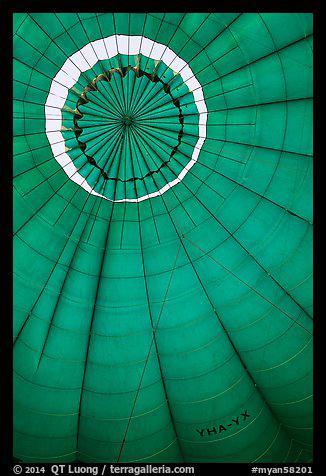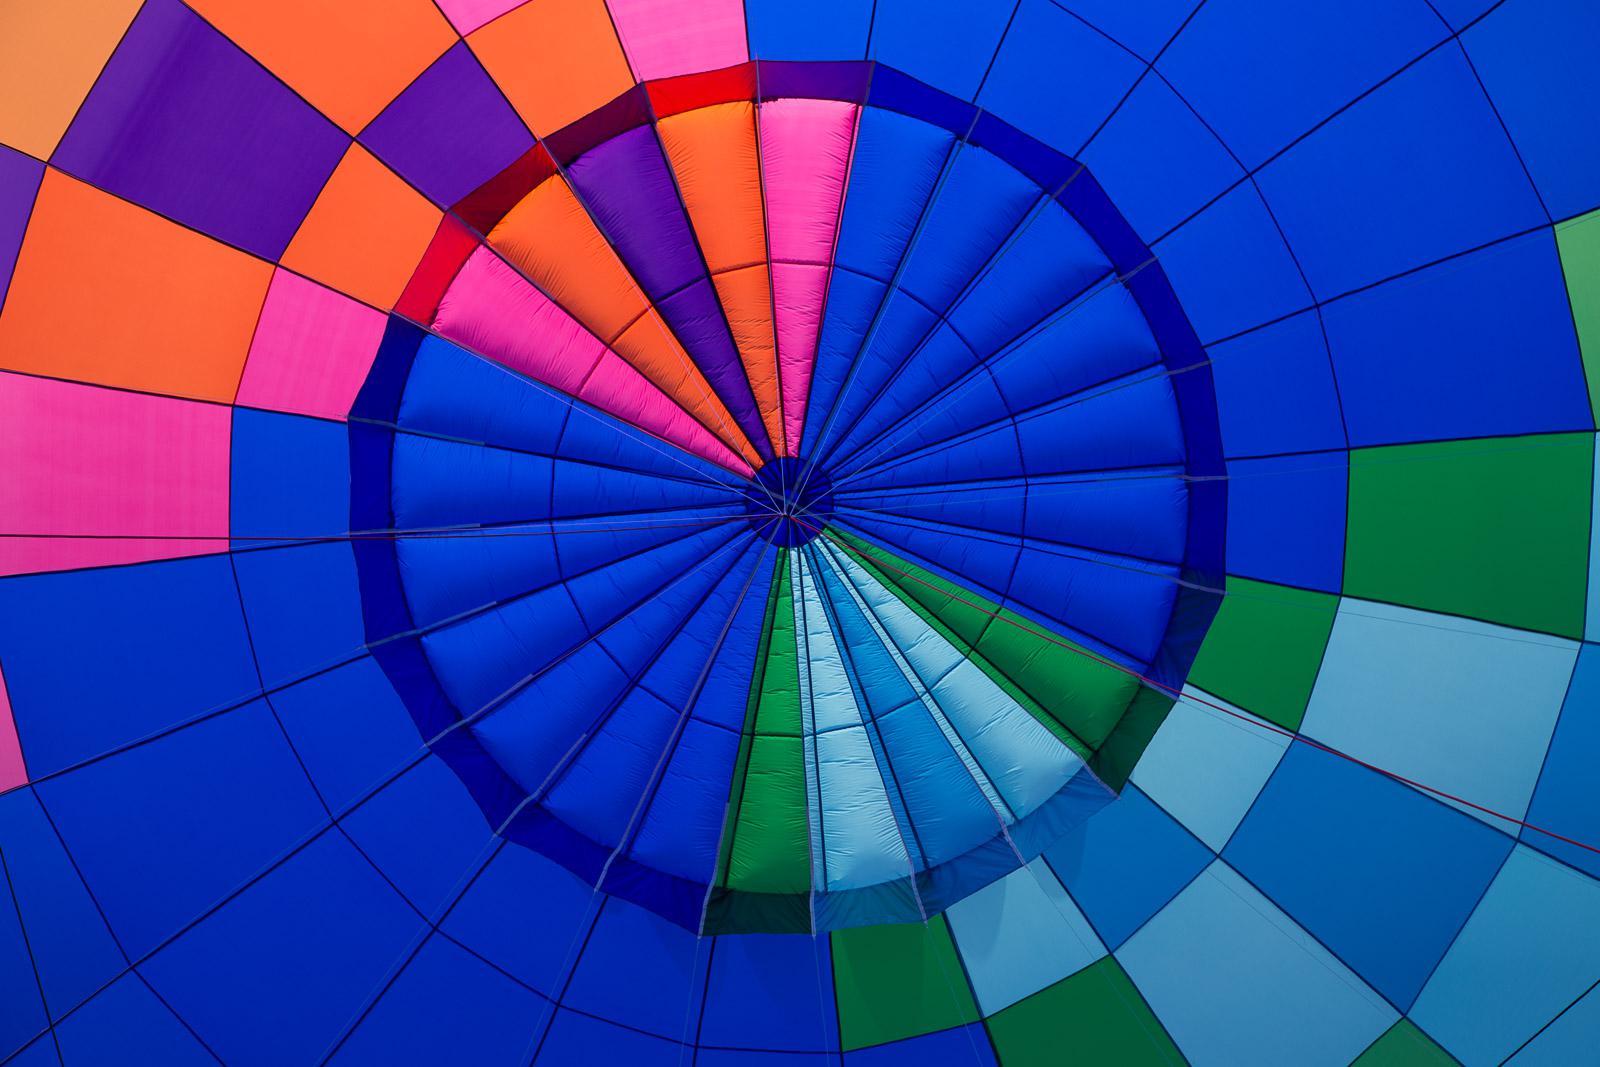The first image is the image on the left, the second image is the image on the right. For the images shown, is this caption "The parachute in the right image contains at least four colors." true? Answer yes or no. Yes. The first image is the image on the left, the second image is the image on the right. Given the left and right images, does the statement "There is a person in one of the images" hold true? Answer yes or no. No. 